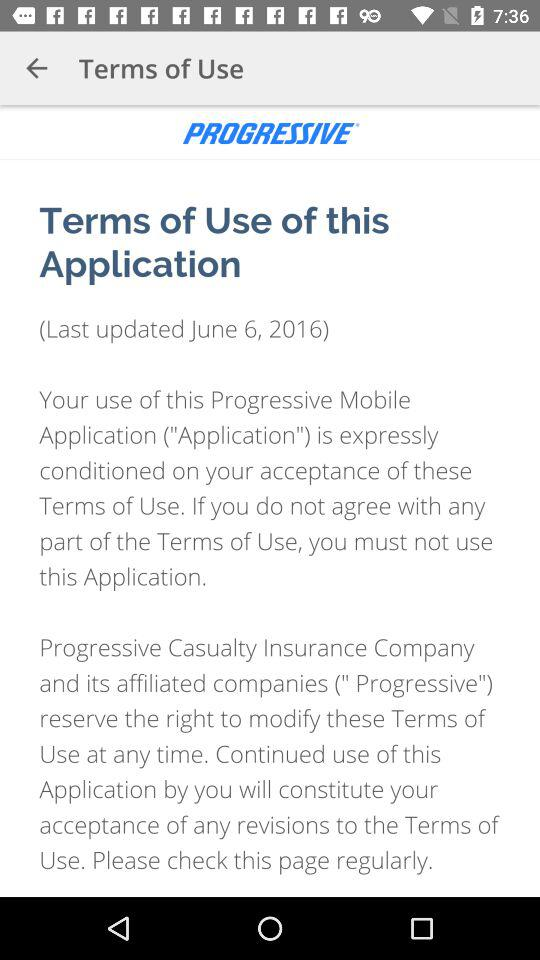When was the application last updated? The application was last updated on June 6, 2016. 